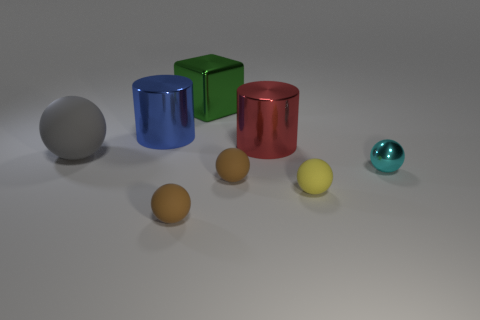Subtract all small yellow rubber spheres. How many spheres are left? 4 Add 1 small metallic objects. How many objects exist? 9 Subtract 3 balls. How many balls are left? 2 Subtract all gray spheres. How many spheres are left? 4 Subtract all cylinders. How many objects are left? 6 Subtract all brown cubes. Subtract all cyan cylinders. How many cubes are left? 1 Subtract all cyan balls. How many green cylinders are left? 0 Subtract all tiny yellow cubes. Subtract all blue objects. How many objects are left? 7 Add 3 big red cylinders. How many big red cylinders are left? 4 Add 8 big yellow rubber cylinders. How many big yellow rubber cylinders exist? 8 